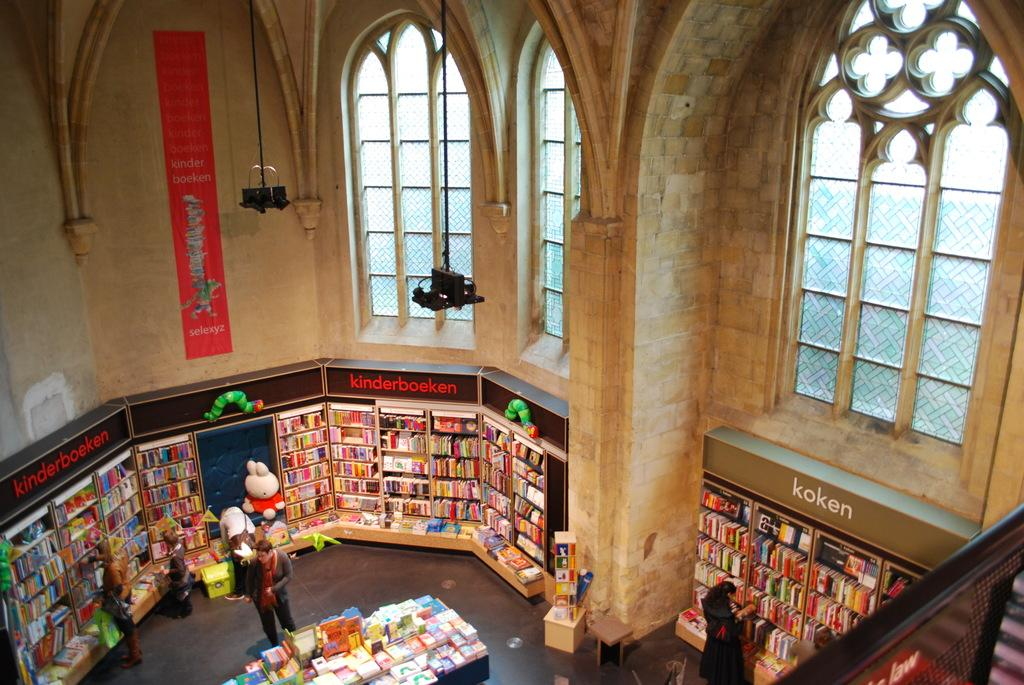<image>
Render a clear and concise summary of the photo. Bookstore inside of a church building with genres such as koken and kinderboeken. 